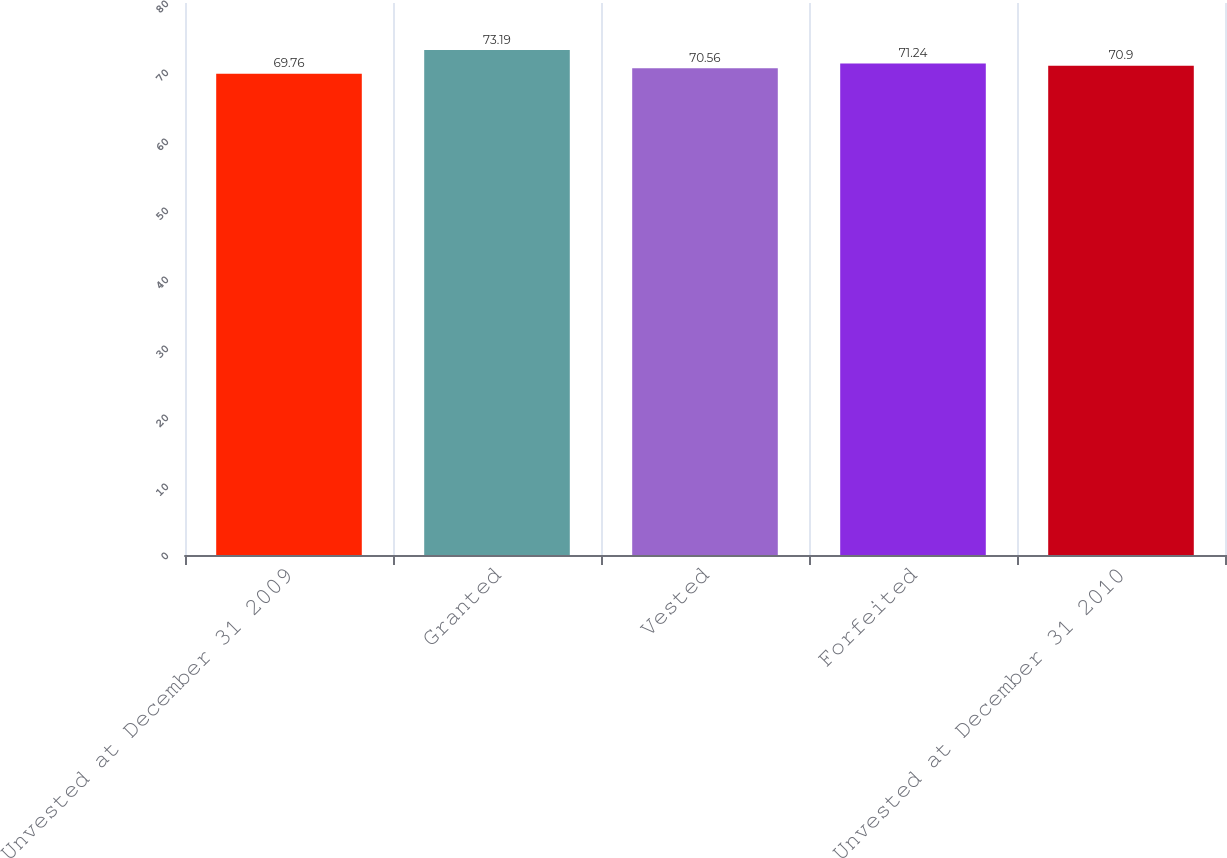<chart> <loc_0><loc_0><loc_500><loc_500><bar_chart><fcel>Unvested at December 31 2009<fcel>Granted<fcel>Vested<fcel>Forfeited<fcel>Unvested at December 31 2010<nl><fcel>69.76<fcel>73.19<fcel>70.56<fcel>71.24<fcel>70.9<nl></chart> 